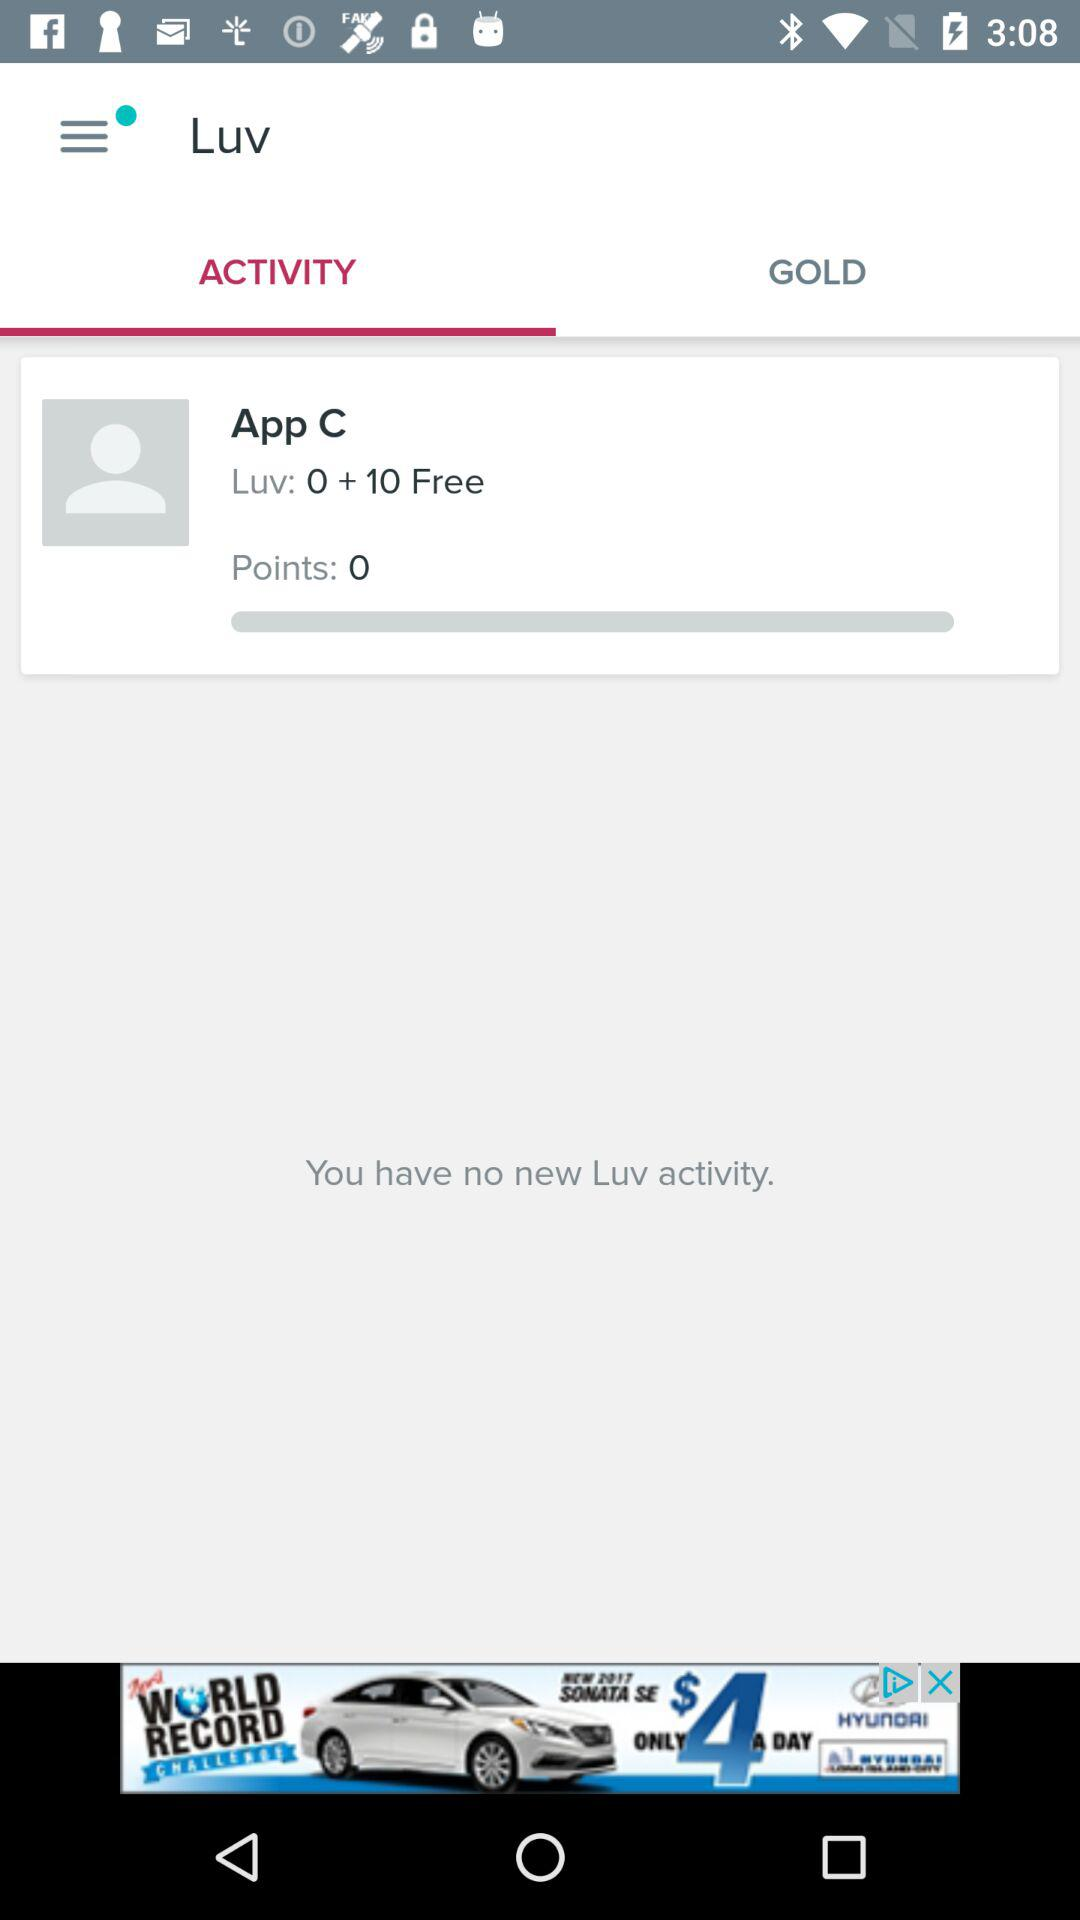How many free Luv does the user have?
Answer the question using a single word or phrase. 10 